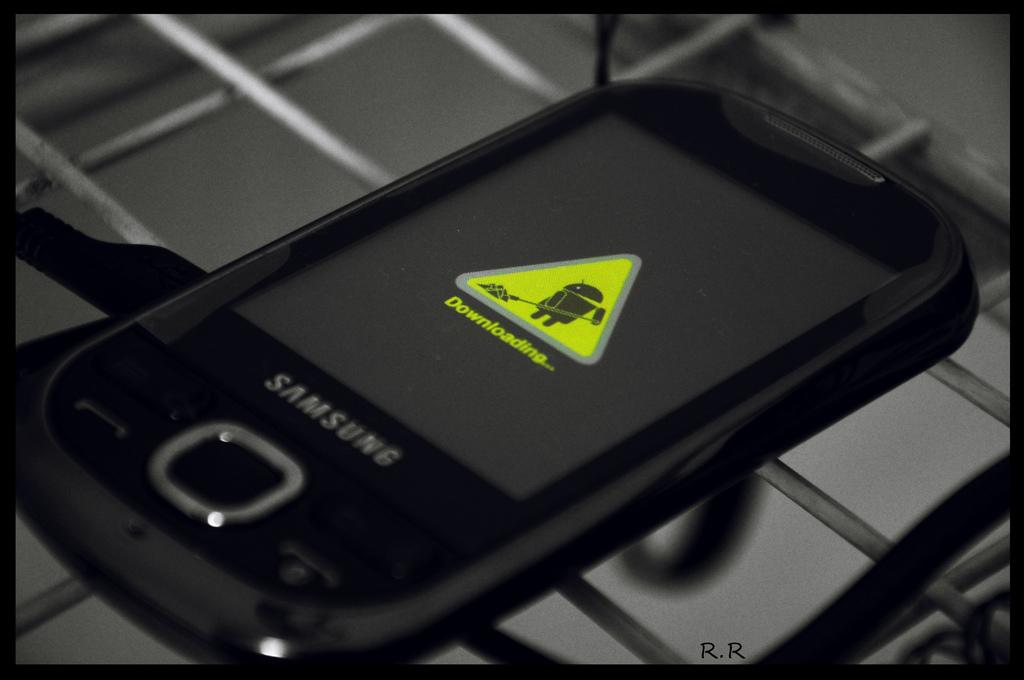<image>
Offer a succinct explanation of the picture presented. A black Samsung phone displays a downloading message on its screen. 